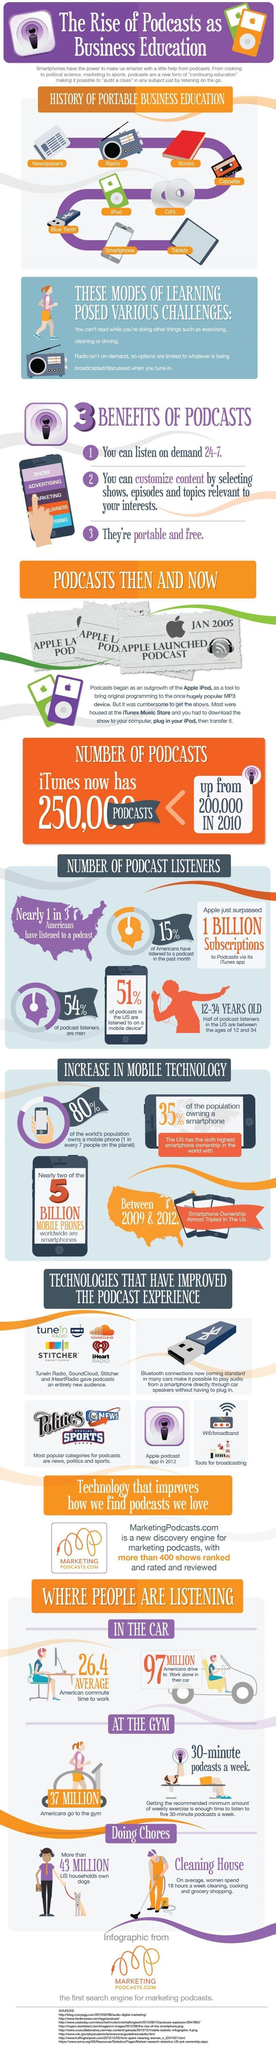What percentage of podcasts listeners in America are women?
Answer the question with a short phrase. 46% What population of Americans go to the gym? 37 MILLION What percent of world's population do not own a mobile phone? 20% What percent of podcasts in the US are listened to on a mobile device? 51% What is the average American commute time to work? 26.4 What is the number of podcasts in iTunes in 2010? 200,000 When did Apple launched Podcast? JAN 2005 